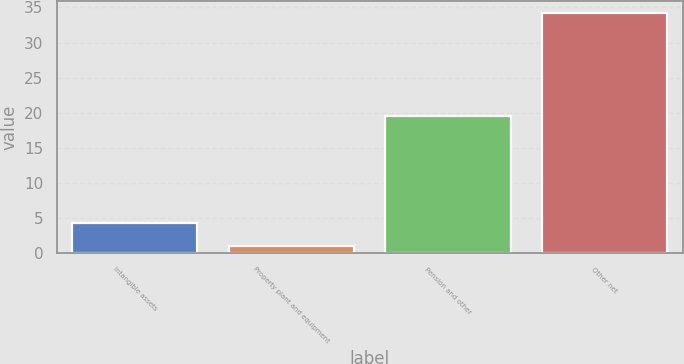Convert chart. <chart><loc_0><loc_0><loc_500><loc_500><bar_chart><fcel>Intangible assets<fcel>Property plant and equipment<fcel>Pension and other<fcel>Other net<nl><fcel>4.32<fcel>1<fcel>19.6<fcel>34.2<nl></chart> 